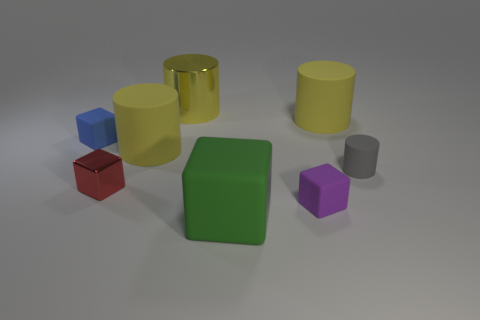How many yellow cylinders must be subtracted to get 1 yellow cylinders? 2 Subtract all large metal cylinders. How many cylinders are left? 3 Add 1 small red metallic objects. How many objects exist? 9 Subtract all purple cubes. How many cubes are left? 3 Subtract 1 cubes. How many cubes are left? 3 Subtract all blue cylinders. How many yellow cubes are left? 0 Subtract all rubber cylinders. Subtract all small blue objects. How many objects are left? 4 Add 8 green rubber things. How many green rubber things are left? 9 Add 7 metallic cylinders. How many metallic cylinders exist? 8 Subtract 0 cyan spheres. How many objects are left? 8 